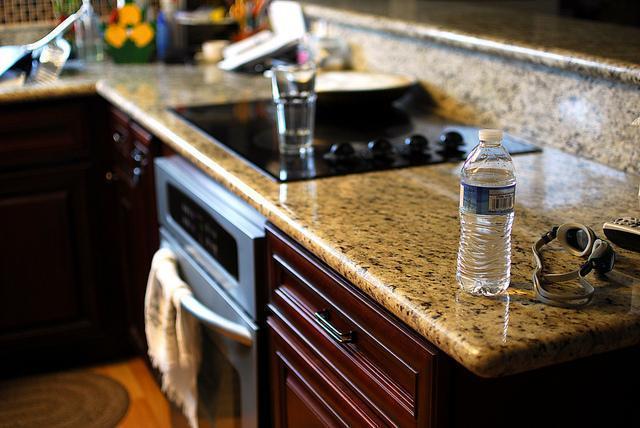The item next to the water bottle is usually used in what setting?
Choose the right answer from the provided options to respond to the question.
Options: Pool, gas station, police station, school. Pool. 